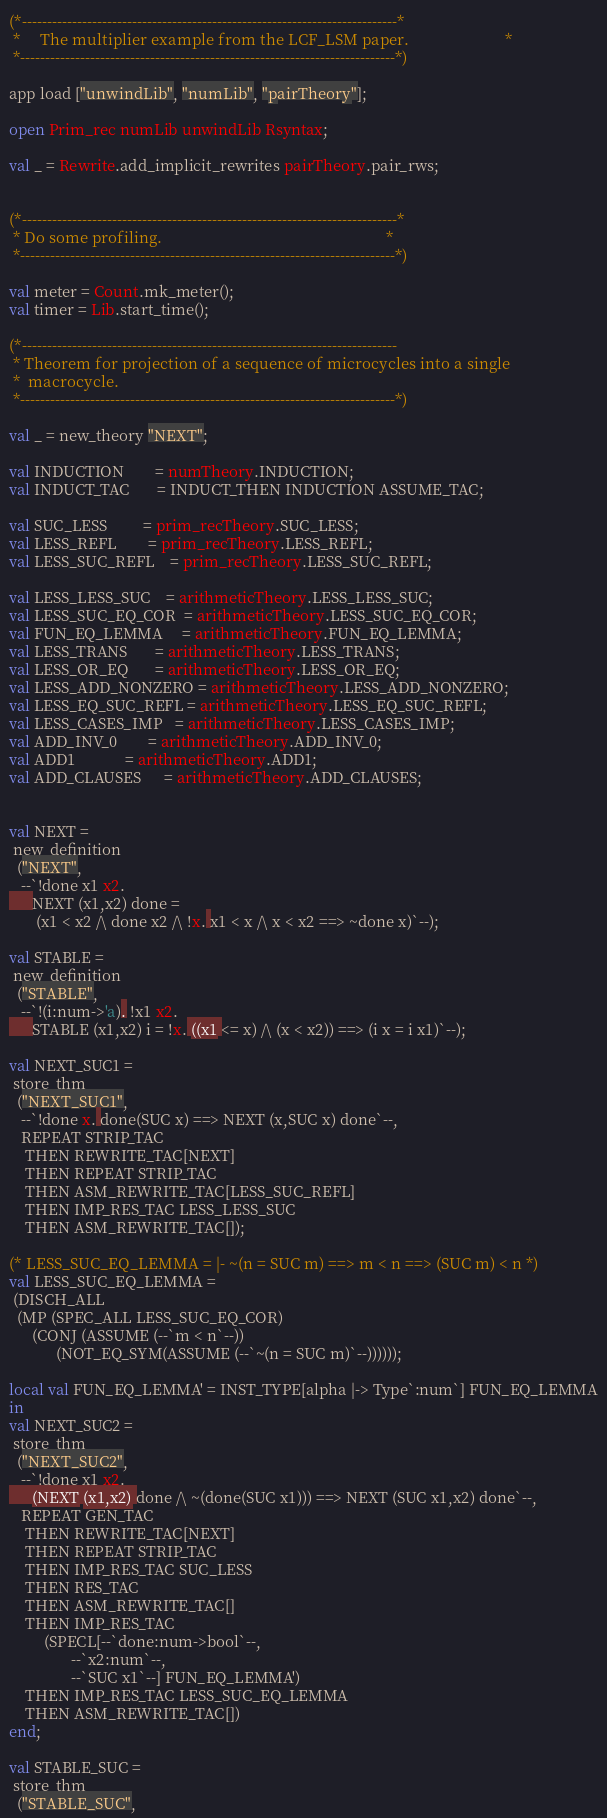Convert code to text. <code><loc_0><loc_0><loc_500><loc_500><_SML_>(*---------------------------------------------------------------------------*
 *     The multiplier example from the LCF_LSM paper.                        *
 *---------------------------------------------------------------------------*)

app load ["unwindLib", "numLib", "pairTheory"];

open Prim_rec numLib unwindLib Rsyntax;

val _ = Rewrite.add_implicit_rewrites pairTheory.pair_rws;


(*---------------------------------------------------------------------------*
 * Do some profiling.                                                        *
 *---------------------------------------------------------------------------*)

val meter = Count.mk_meter();
val timer = Lib.start_time();

(*---------------------------------------------------------------------------
 * Theorem for projection of a sequence of microcycles into a single
 *  macrocycle.
 *---------------------------------------------------------------------------*)

val _ = new_theory "NEXT";

val INDUCTION        = numTheory.INDUCTION;
val INDUCT_TAC       = INDUCT_THEN INDUCTION ASSUME_TAC;

val SUC_LESS         = prim_recTheory.SUC_LESS;
val LESS_REFL        = prim_recTheory.LESS_REFL;
val LESS_SUC_REFL    = prim_recTheory.LESS_SUC_REFL;

val LESS_LESS_SUC    = arithmeticTheory.LESS_LESS_SUC;
val LESS_SUC_EQ_COR  = arithmeticTheory.LESS_SUC_EQ_COR;
val FUN_EQ_LEMMA     = arithmeticTheory.FUN_EQ_LEMMA;
val LESS_TRANS       = arithmeticTheory.LESS_TRANS;
val LESS_OR_EQ       = arithmeticTheory.LESS_OR_EQ;
val LESS_ADD_NONZERO = arithmeticTheory.LESS_ADD_NONZERO;
val LESS_EQ_SUC_REFL = arithmeticTheory.LESS_EQ_SUC_REFL;
val LESS_CASES_IMP   = arithmeticTheory.LESS_CASES_IMP;
val ADD_INV_0        = arithmeticTheory.ADD_INV_0;
val ADD1             = arithmeticTheory.ADD1;
val ADD_CLAUSES      = arithmeticTheory.ADD_CLAUSES;


val NEXT =
 new_definition
  ("NEXT",
   --`!done x1 x2.
      NEXT (x1,x2) done =
       (x1 < x2 /\ done x2 /\ !x. x1 < x /\ x < x2 ==> ~done x)`--);

val STABLE =
 new_definition
  ("STABLE",
   --`!(i:num->'a). !x1 x2.
      STABLE (x1,x2) i = !x. ((x1 <= x) /\ (x < x2)) ==> (i x = i x1)`--);

val NEXT_SUC1 =
 store_thm
  ("NEXT_SUC1",
   --`!done x. done(SUC x) ==> NEXT (x,SUC x) done`--,
   REPEAT STRIP_TAC
    THEN REWRITE_TAC[NEXT]
    THEN REPEAT STRIP_TAC
    THEN ASM_REWRITE_TAC[LESS_SUC_REFL]
    THEN IMP_RES_TAC LESS_LESS_SUC
    THEN ASM_REWRITE_TAC[]);

(* LESS_SUC_EQ_LEMMA = |- ~(n = SUC m) ==> m < n ==> (SUC m) < n *)
val LESS_SUC_EQ_LEMMA =
 (DISCH_ALL
  (MP (SPEC_ALL LESS_SUC_EQ_COR)
      (CONJ (ASSUME (--`m < n`--))
            (NOT_EQ_SYM(ASSUME (--`~(n = SUC m)`--))))));

local val FUN_EQ_LEMMA' = INST_TYPE[alpha |-> Type`:num`] FUN_EQ_LEMMA
in
val NEXT_SUC2 =
 store_thm
  ("NEXT_SUC2",
   --`!done x1 x2.
      (NEXT (x1,x2) done /\ ~(done(SUC x1))) ==> NEXT (SUC x1,x2) done`--,
   REPEAT GEN_TAC
    THEN REWRITE_TAC[NEXT]
    THEN REPEAT STRIP_TAC
    THEN IMP_RES_TAC SUC_LESS
    THEN RES_TAC
    THEN ASM_REWRITE_TAC[]
    THEN IMP_RES_TAC
         (SPECL[--`done:num->bool`--,
                --`x2:num`--,
                --`SUC x1`--] FUN_EQ_LEMMA')
    THEN IMP_RES_TAC LESS_SUC_EQ_LEMMA
    THEN ASM_REWRITE_TAC[])
end;

val STABLE_SUC =
 store_thm
  ("STABLE_SUC",</code> 